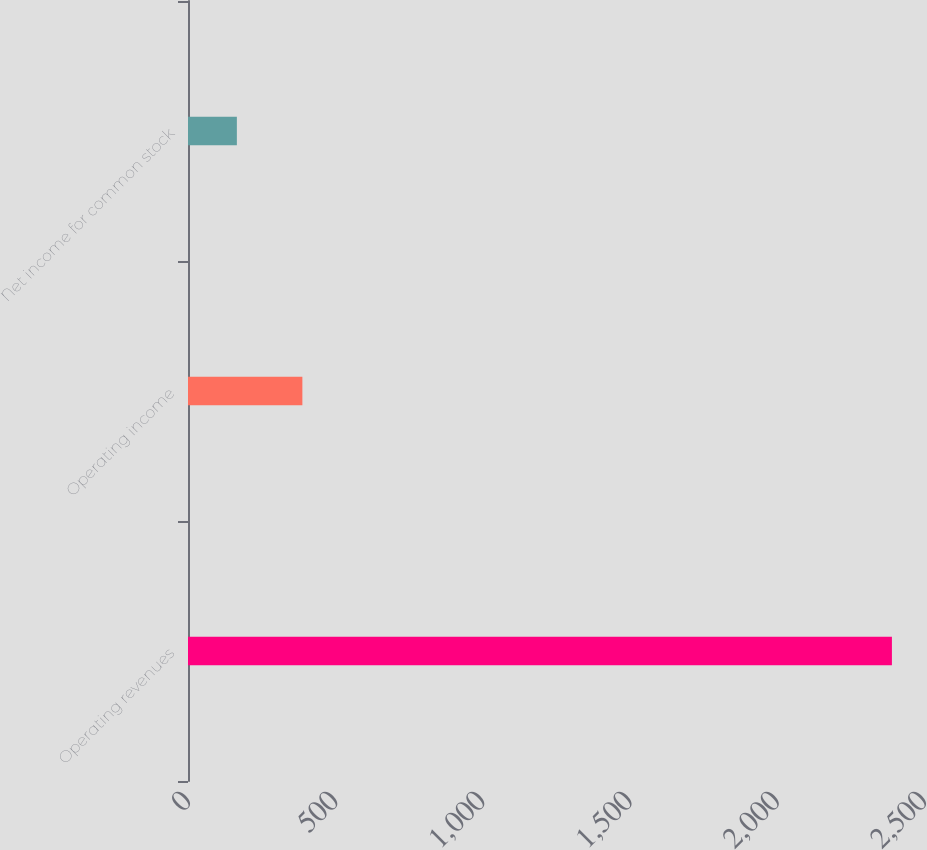Convert chart to OTSL. <chart><loc_0><loc_0><loc_500><loc_500><bar_chart><fcel>Operating revenues<fcel>Operating income<fcel>Net income for common stock<nl><fcel>2391<fcel>388.5<fcel>166<nl></chart> 